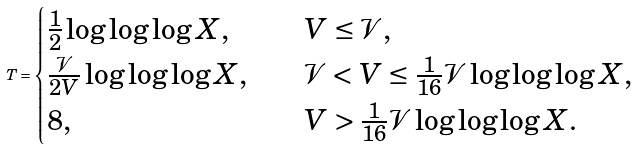Convert formula to latex. <formula><loc_0><loc_0><loc_500><loc_500>T = \begin{cases} \frac { 1 } { 2 } \log \log \log X , \quad \ \ & V \leq \mathcal { V } , \\ \frac { \mathcal { V } } { 2 V } \log \log \log X , & \mathcal { V } < V \leq \frac { 1 } { 1 6 } \mathcal { V } \log \log \log X , \\ 8 , & V > \frac { 1 } { 1 6 } \mathcal { V } \log \log \log X . \end{cases}</formula> 